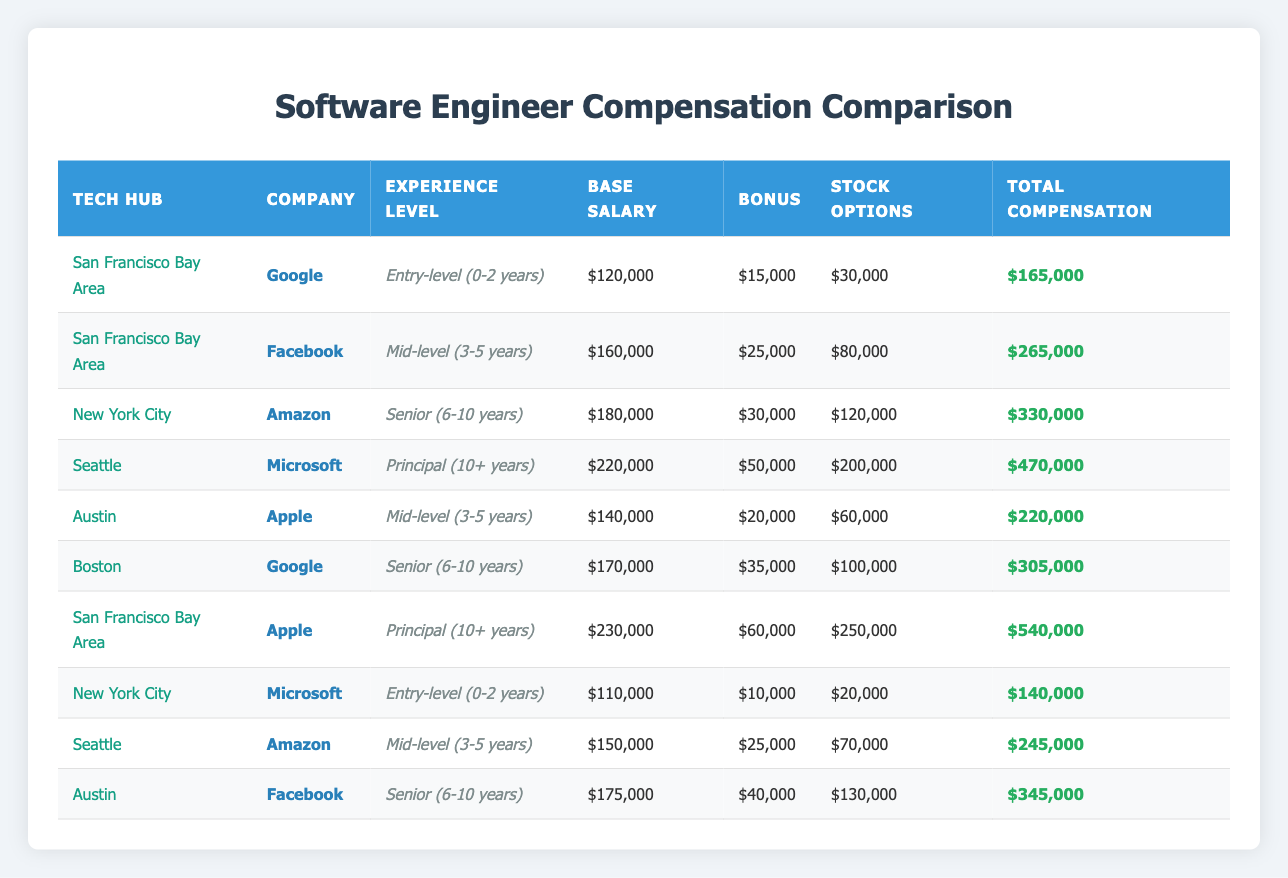What is the total compensation for a Mid-level software engineer at Facebook in the San Francisco Bay Area? According to the table, the total compensation for a Mid-level software engineer at Facebook in the San Francisco Bay Area is listed specifically, which is $265,000.
Answer: $265,000 Which company offers the highest total compensation for a Principal-level software engineer? By comparing the total compensation across the companies for Principal-level software engineers, it's clear that Apple in the San Francisco Bay Area offers the highest total compensation at $540,000.
Answer: $540,000 What is the difference in total compensation between an Entry-level software engineer at Google in the San Francisco Bay Area and at Microsoft in New York City? The total compensation for Google in the San Francisco Bay Area is $165,000 and for Microsoft in New York City is $140,000. The difference is $165,000 - $140,000 = $25,000.
Answer: $25,000 Is the stock options component higher for Senior software engineers at Amazon in Seattle compared to those at Facebook in Austin? The stock options for Senior engineers at Amazon in Seattle are $120,000, while at Facebook in Austin they are $130,000. Therefore, the statement is false as Facebook offers higher stock options.
Answer: No Which tech hub has the highest average total compensation for Mid-level software engineers, based on the data provided? Calculate the total compensation for Mid-level engineers: Facebook in San Francisco Bay Area has $265,000, Amazon in Seattle has $245,000, and Apple in Austin has $220,000. The average is ($265,000 + $245,000 + $220,000) / 3 = $243,333. San Francisco Bay Area offers the highest average.
Answer: San Francisco Bay Area What is the total base salary for Senior software engineers across all hubs? The base salaries for Senior software engineers are: $180,000 (Amazon, NYC), $175,000 (Facebook, Austin), and $170,000 (Google, Boston). Thus, the total is $180,000 + $175,000 + $170,000 = $525,000.
Answer: $525,000 Are there more companies offering higher total compensation for Principal software engineers than for Entry-level engineers in the San Francisco Bay Area? In the San Francisco Bay Area, there are two companies (Google and Apple) listed for Principal-level with total compensations of $165,000 and $540,000 respectively and one company (Google) for Entry-level compensation. Thus, the answer is yes, as there are more Principal positions listed.
Answer: Yes What is the highest total compensation among all the software engineers listed in the table? The highest total compensation across all entries in the table is $540,000 for a Principal software engineer at Apple in the San Francisco Bay Area.
Answer: $540,000 